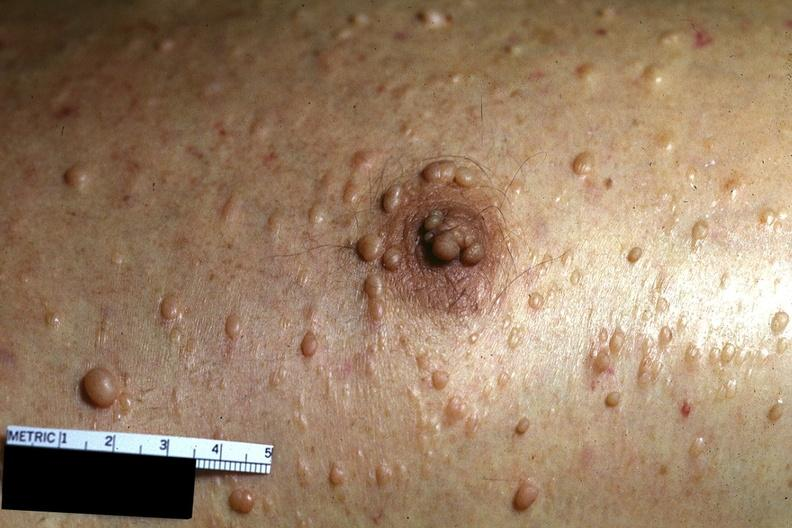does craniopharyngioma show skin, neurofibromatosis?
Answer the question using a single word or phrase. No 